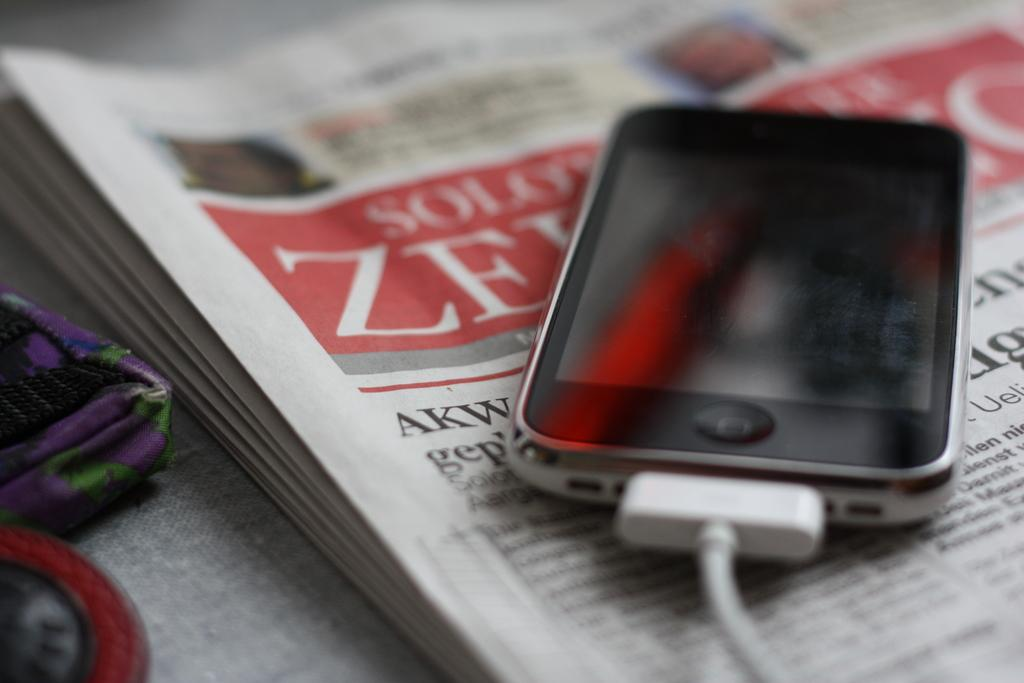Where was the image taken? The image was taken indoors. What piece of furniture is present in the image? There is a table in the image. What is covering the table? The table has a tablecloth on it. What items can be seen on the table? There is a pouch, a newspaper, and a mobile phone with a charger on the table. What type of lawyer is featured in the image? There is no lawyer present in the image. What achievements are highlighted in the image? The image does not show any achievements or values; it simply depicts a table with various items on it. 